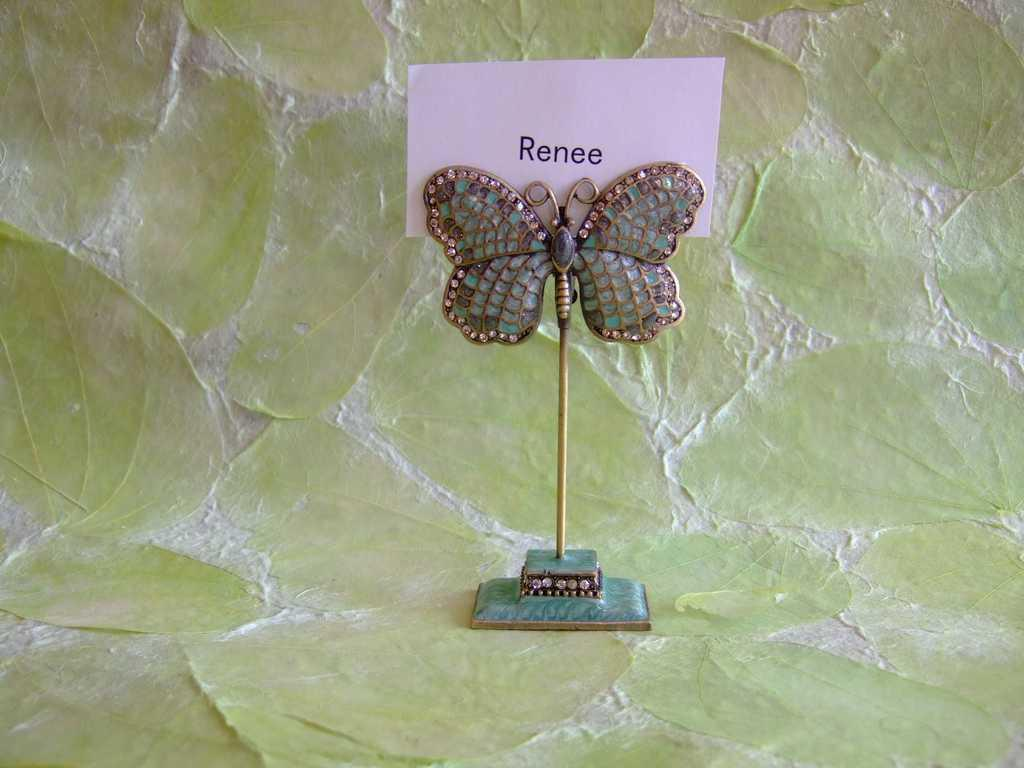What can be seen on the surface in the image? There is an object on the surface in the image. What is the color of the background on the backside of the object? The backside of the object has a green color background. What is attached to the object in the image? There is a white paper with text attached to the object. How many lizards can be seen crawling on the object in the image? There are no lizards present in the image. What type of breath is required to interact with the object in the image? The image does not depict any interaction with the object that would require a specific type of breath. 